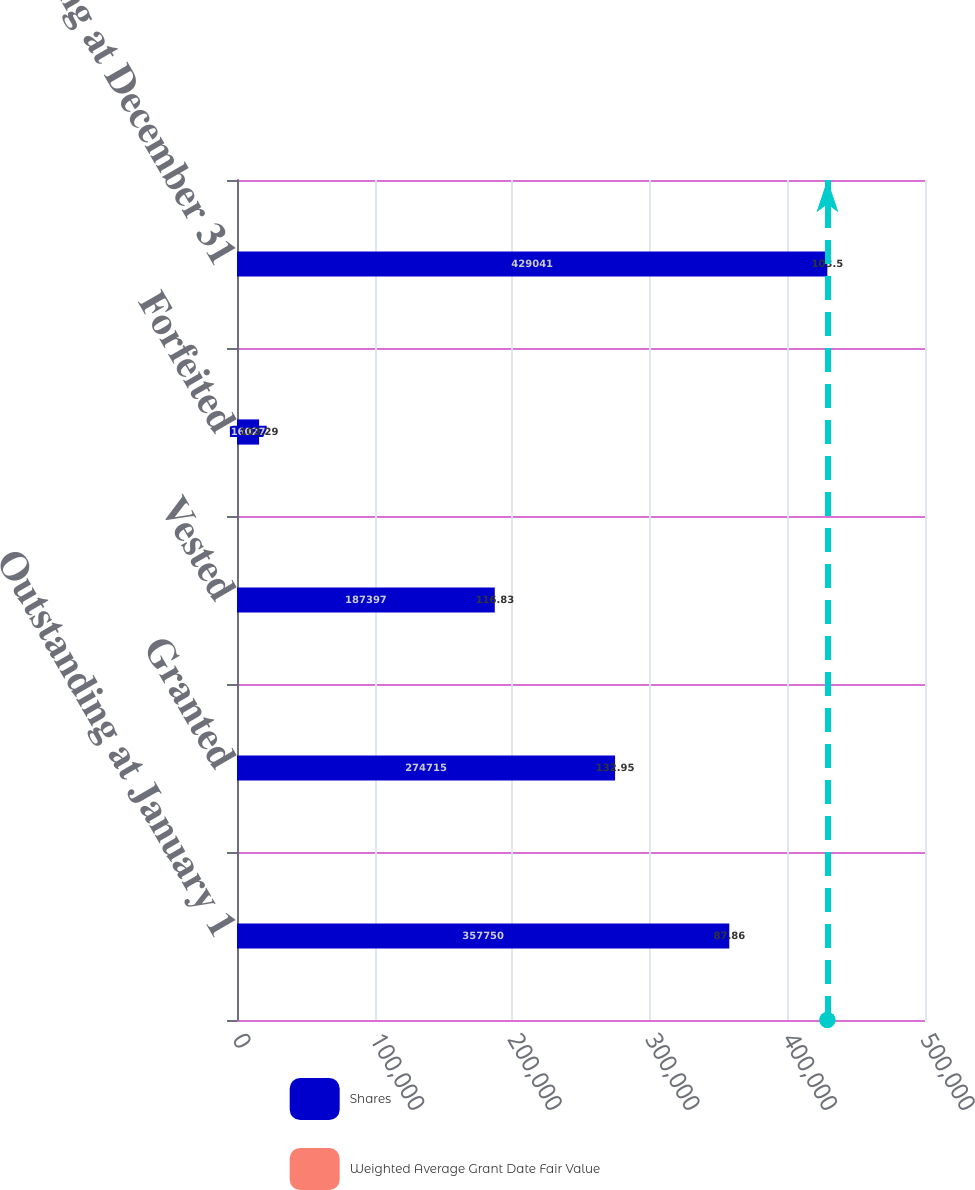Convert chart to OTSL. <chart><loc_0><loc_0><loc_500><loc_500><stacked_bar_chart><ecel><fcel>Outstanding at January 1<fcel>Granted<fcel>Vested<fcel>Forfeited<fcel>Outstanding at December 31<nl><fcel>Shares<fcel>357750<fcel>274715<fcel>187397<fcel>16027<fcel>429041<nl><fcel>Weighted Average Grant Date Fair Value<fcel>87.86<fcel>132.95<fcel>116.83<fcel>103.29<fcel>103.5<nl></chart> 